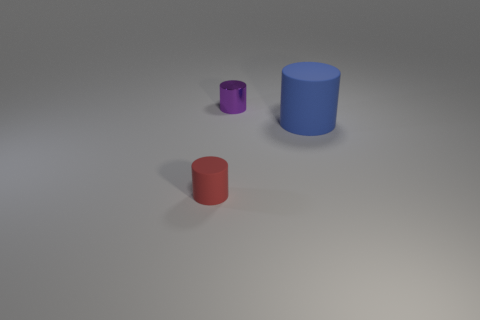Is the size of the red cylinder the same as the cylinder to the right of the small shiny thing?
Offer a very short reply. No. What is the size of the metal object?
Provide a succinct answer. Small. The tiny object that is the same material as the large blue object is what color?
Keep it short and to the point. Red. What number of other cylinders have the same material as the red cylinder?
Offer a very short reply. 1. What number of objects are either tiny purple shiny cylinders or purple things to the left of the big thing?
Provide a short and direct response. 1. Does the object on the right side of the small purple shiny cylinder have the same material as the small purple thing?
Provide a short and direct response. No. There is a cylinder that is the same size as the red matte object; what color is it?
Offer a terse response. Purple. Is there a tiny gray matte thing that has the same shape as the big blue object?
Ensure brevity in your answer.  No. The tiny cylinder that is to the left of the cylinder behind the cylinder that is to the right of the metallic thing is what color?
Your answer should be compact. Red. What number of shiny things are either big gray cylinders or large cylinders?
Your answer should be compact. 0. 